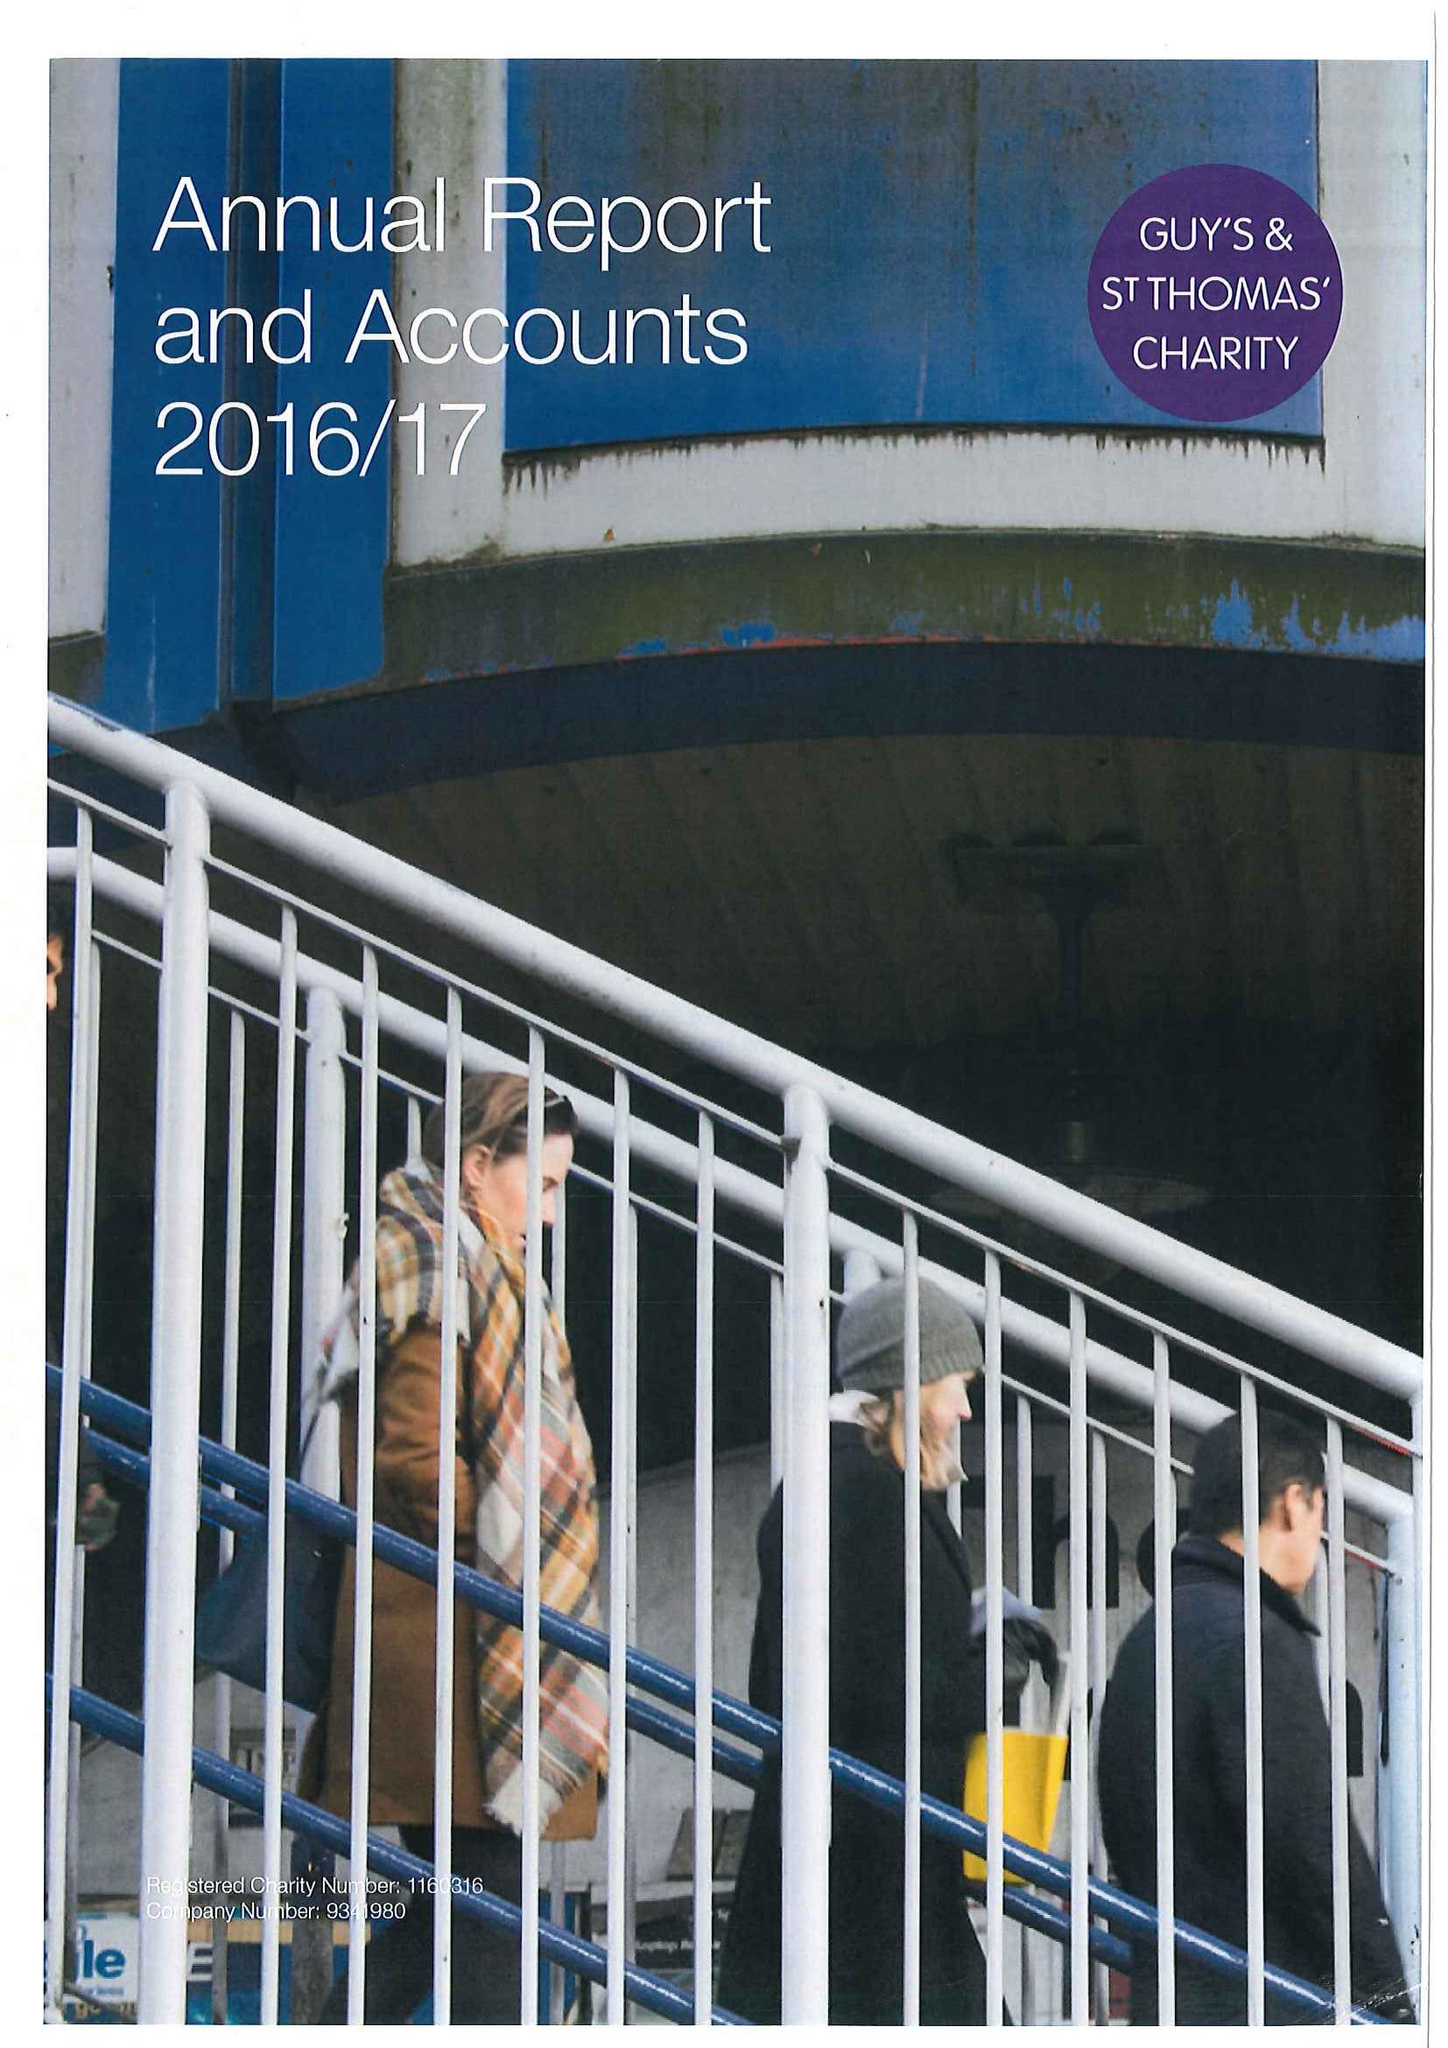What is the value for the report_date?
Answer the question using a single word or phrase. 2017-03-31 